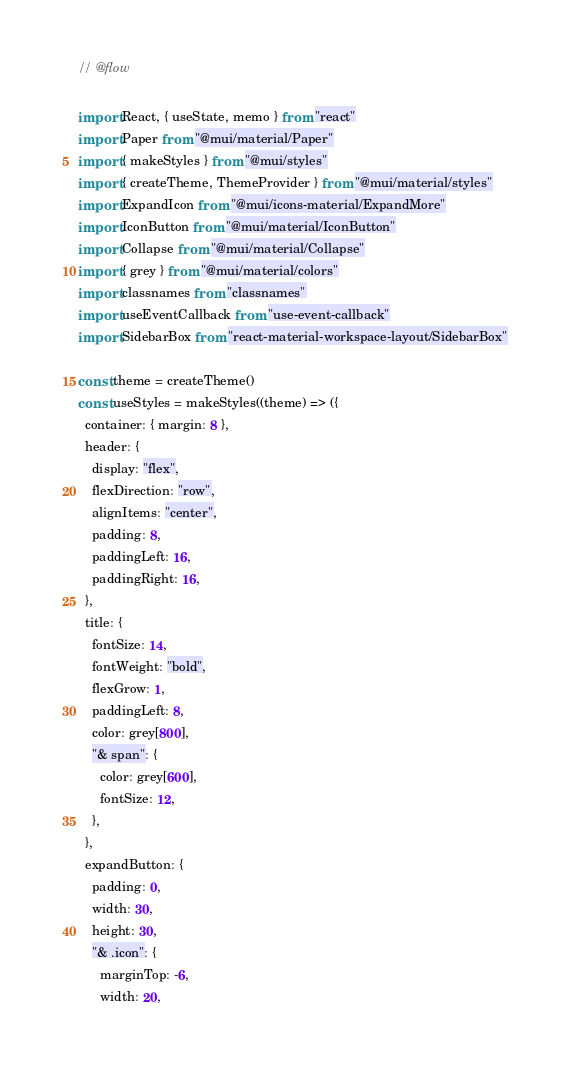Convert code to text. <code><loc_0><loc_0><loc_500><loc_500><_JavaScript_>// @flow

import React, { useState, memo } from "react"
import Paper from "@mui/material/Paper"
import { makeStyles } from "@mui/styles"
import { createTheme, ThemeProvider } from "@mui/material/styles"
import ExpandIcon from "@mui/icons-material/ExpandMore"
import IconButton from "@mui/material/IconButton"
import Collapse from "@mui/material/Collapse"
import { grey } from "@mui/material/colors"
import classnames from "classnames"
import useEventCallback from "use-event-callback"
import SidebarBox from "react-material-workspace-layout/SidebarBox"

const theme = createTheme()
const useStyles = makeStyles((theme) => ({
  container: { margin: 8 },
  header: {
    display: "flex",
    flexDirection: "row",
    alignItems: "center",
    padding: 8,
    paddingLeft: 16,
    paddingRight: 16,
  },
  title: {
    fontSize: 14,
    fontWeight: "bold",
    flexGrow: 1,
    paddingLeft: 8,
    color: grey[800],
    "& span": {
      color: grey[600],
      fontSize: 12,
    },
  },
  expandButton: {
    padding: 0,
    width: 30,
    height: 30,
    "& .icon": {
      marginTop: -6,
      width: 20,</code> 